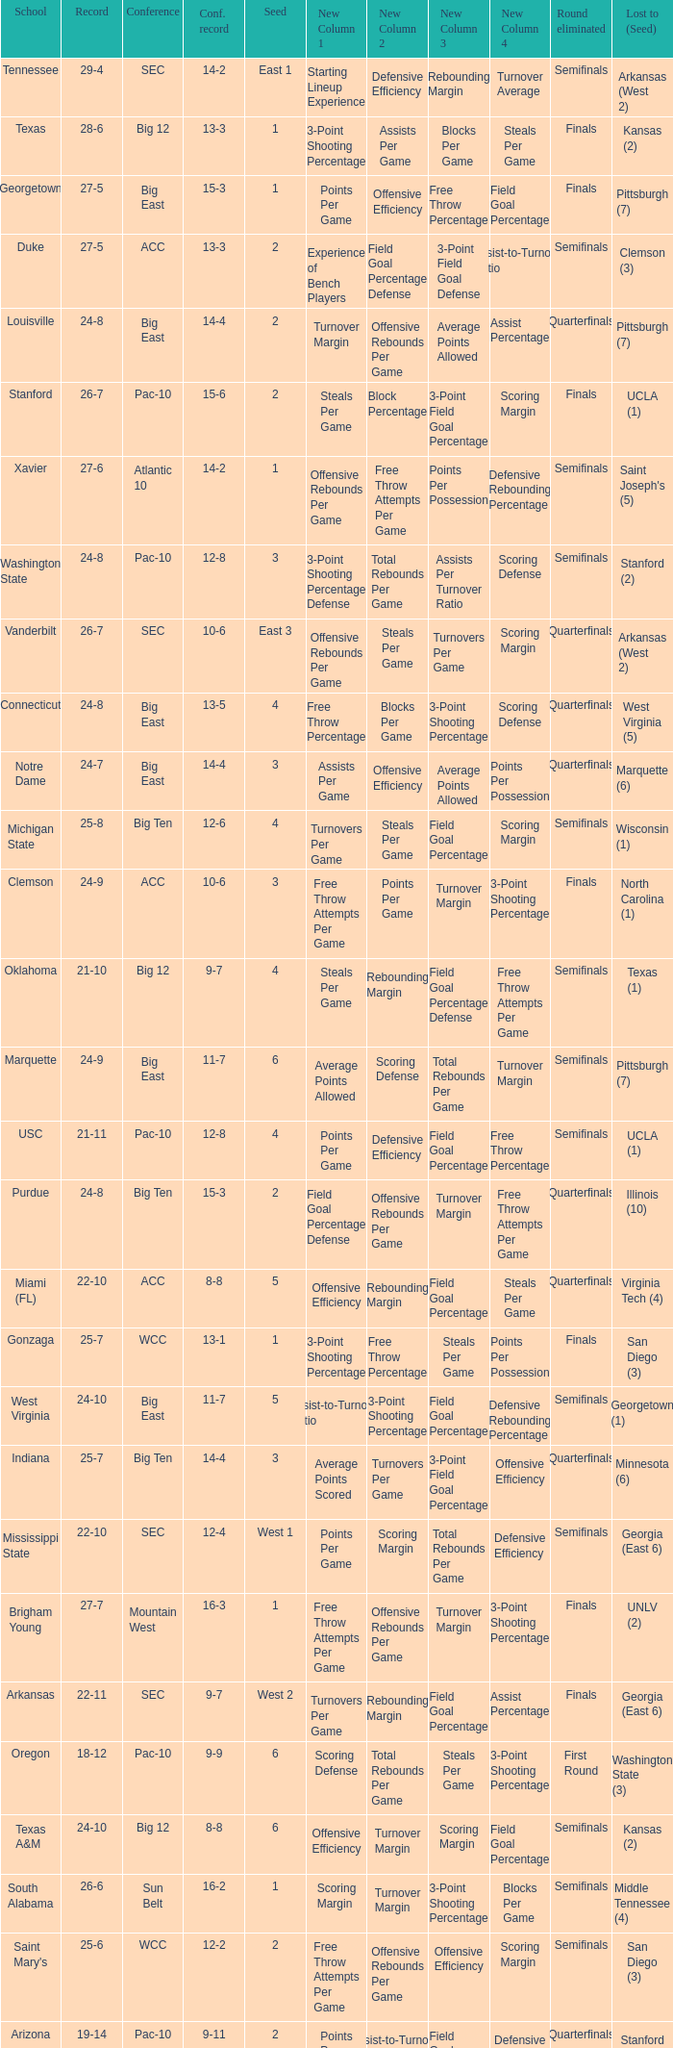Name the round eliminated where conference record is 12-6 Semifinals. 